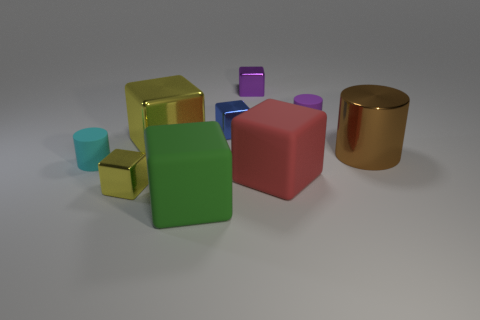What is the shape of the small matte object that is to the left of the yellow object behind the shiny object that is on the right side of the purple metallic cube?
Your answer should be very brief. Cylinder. What is the material of the large block that is in front of the large yellow metal object and on the left side of the purple metal object?
Ensure brevity in your answer.  Rubber. There is a tiny matte cylinder behind the yellow metallic block to the right of the tiny metallic cube that is in front of the big metal cylinder; what color is it?
Ensure brevity in your answer.  Purple. What number of cyan things are small shiny cubes or small things?
Make the answer very short. 1. How many other things are there of the same size as the purple metal block?
Offer a very short reply. 4. What number of large green matte cubes are there?
Your answer should be very brief. 1. Is the material of the cylinder left of the blue object the same as the large cube that is behind the small cyan matte cylinder?
Give a very brief answer. No. What is the green object made of?
Your response must be concise. Rubber. What number of green objects have the same material as the large yellow block?
Offer a very short reply. 0. What number of rubber things are either red balls or big green things?
Your answer should be compact. 1. 